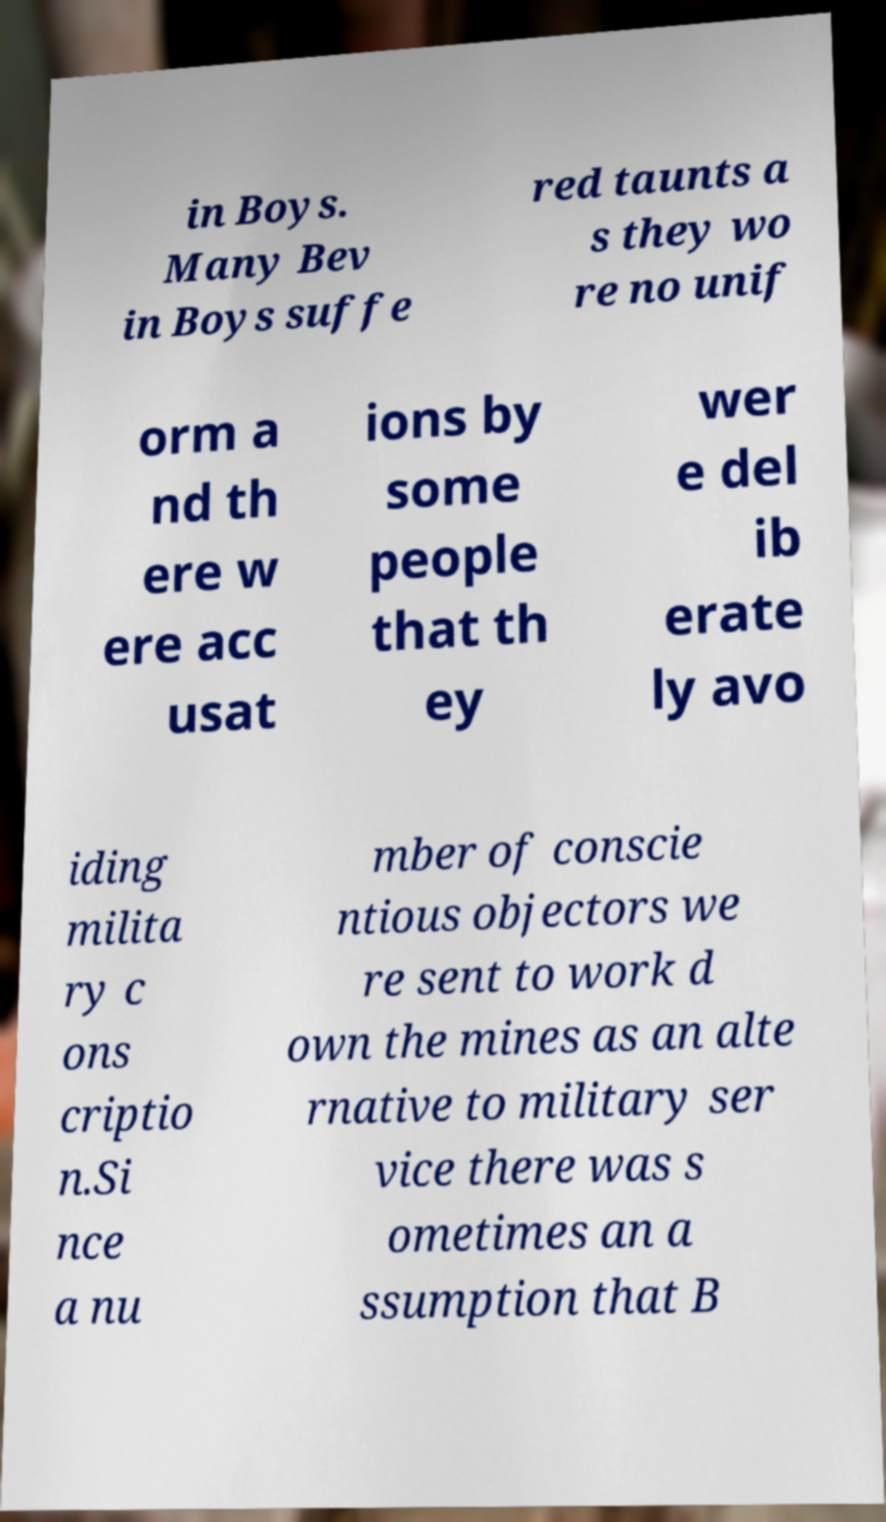There's text embedded in this image that I need extracted. Can you transcribe it verbatim? in Boys. Many Bev in Boys suffe red taunts a s they wo re no unif orm a nd th ere w ere acc usat ions by some people that th ey wer e del ib erate ly avo iding milita ry c ons criptio n.Si nce a nu mber of conscie ntious objectors we re sent to work d own the mines as an alte rnative to military ser vice there was s ometimes an a ssumption that B 